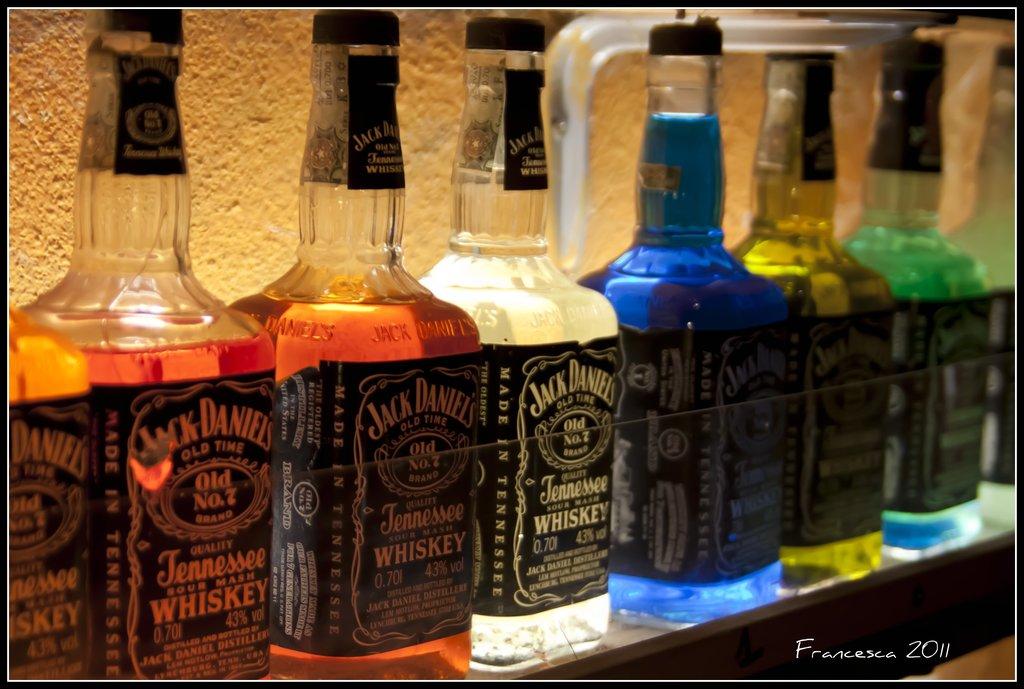What is this brand of liquor?
Offer a very short reply. Jack daniels. Where is the whisky from?
Give a very brief answer. Tennessee. 